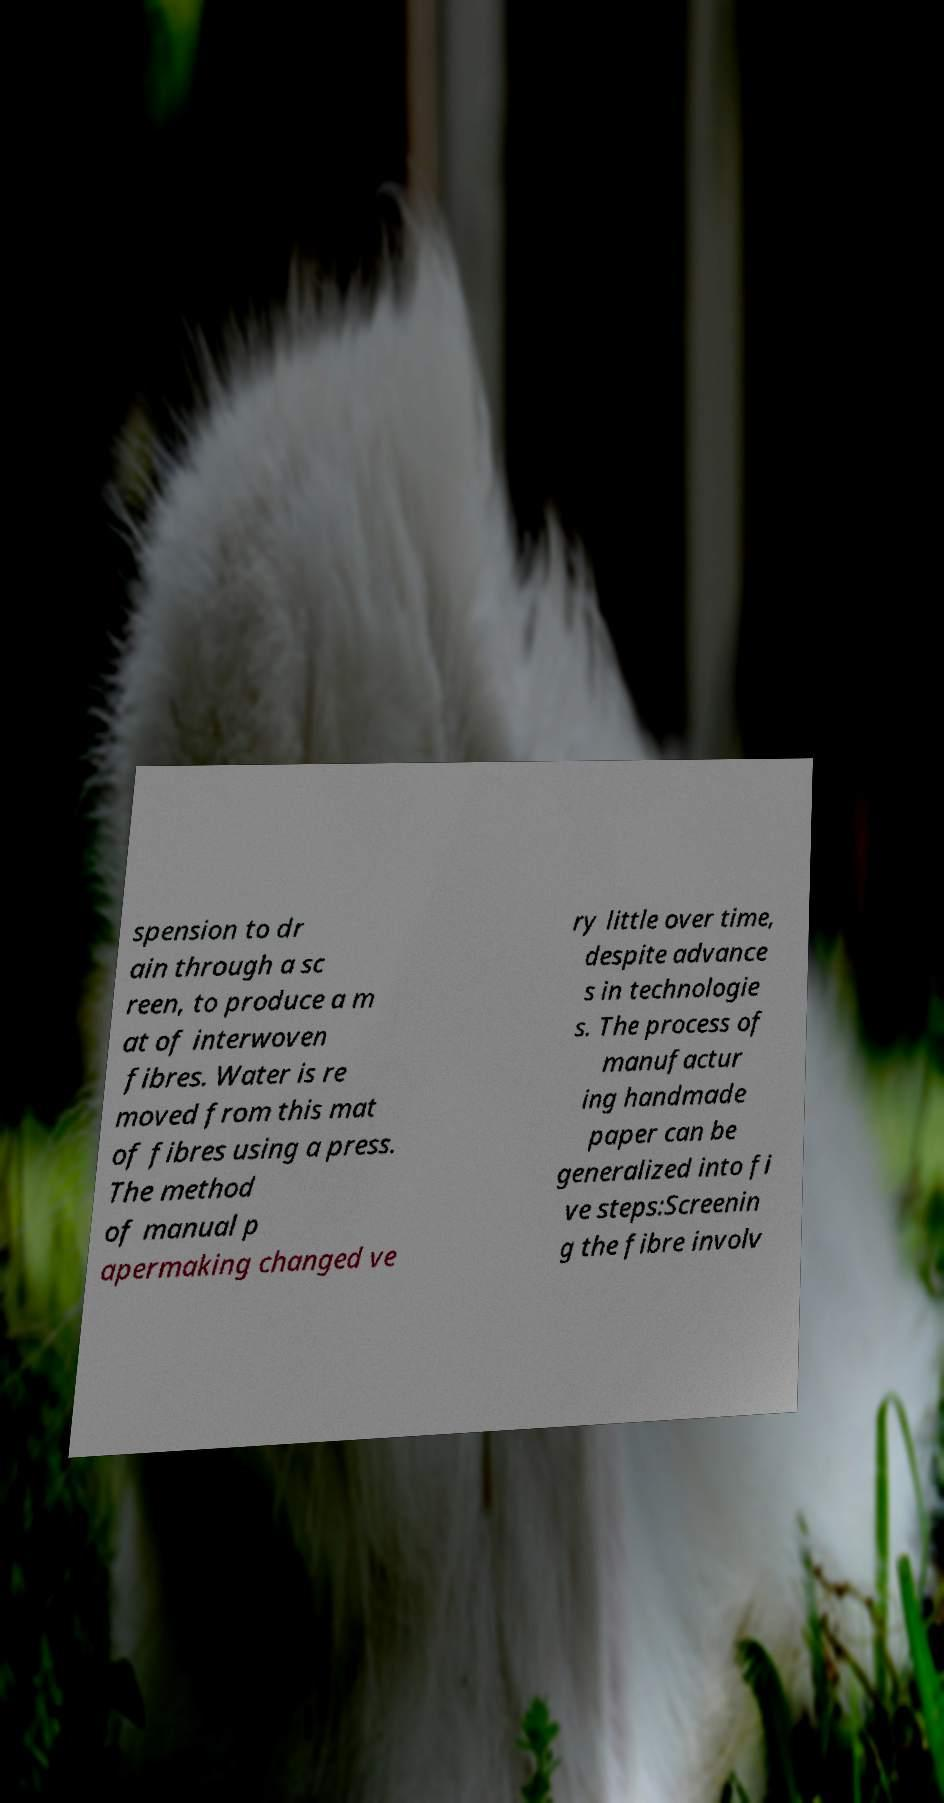I need the written content from this picture converted into text. Can you do that? spension to dr ain through a sc reen, to produce a m at of interwoven fibres. Water is re moved from this mat of fibres using a press. The method of manual p apermaking changed ve ry little over time, despite advance s in technologie s. The process of manufactur ing handmade paper can be generalized into fi ve steps:Screenin g the fibre involv 